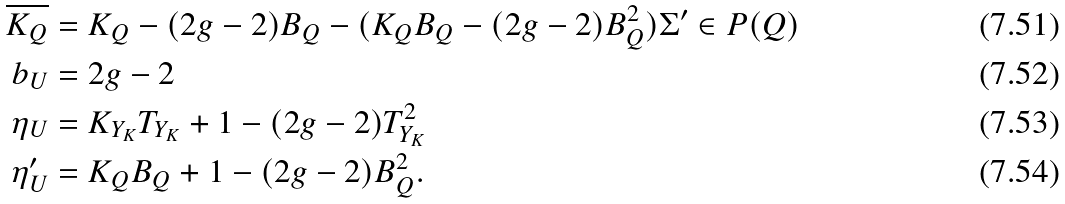Convert formula to latex. <formula><loc_0><loc_0><loc_500><loc_500>\overline { K _ { Q } } & = K _ { Q } - ( 2 g - 2 ) B _ { Q } - ( K _ { Q } B _ { Q } - ( 2 g - 2 ) B _ { Q } ^ { 2 } ) \Sigma ^ { \prime } \in P ( Q ) \\ b _ { U } & = 2 g - 2 \\ \eta _ { U } & = K _ { Y _ { K } } T _ { Y _ { K } } + 1 - ( 2 g - 2 ) T _ { Y _ { K } } ^ { 2 } \\ \eta ^ { \prime } _ { U } & = K _ { Q } B _ { Q } + 1 - ( 2 g - 2 ) B _ { Q } ^ { 2 } .</formula> 